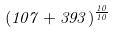<formula> <loc_0><loc_0><loc_500><loc_500>( 1 0 7 + 3 9 3 ) ^ { \frac { 1 0 } { 1 0 } }</formula> 